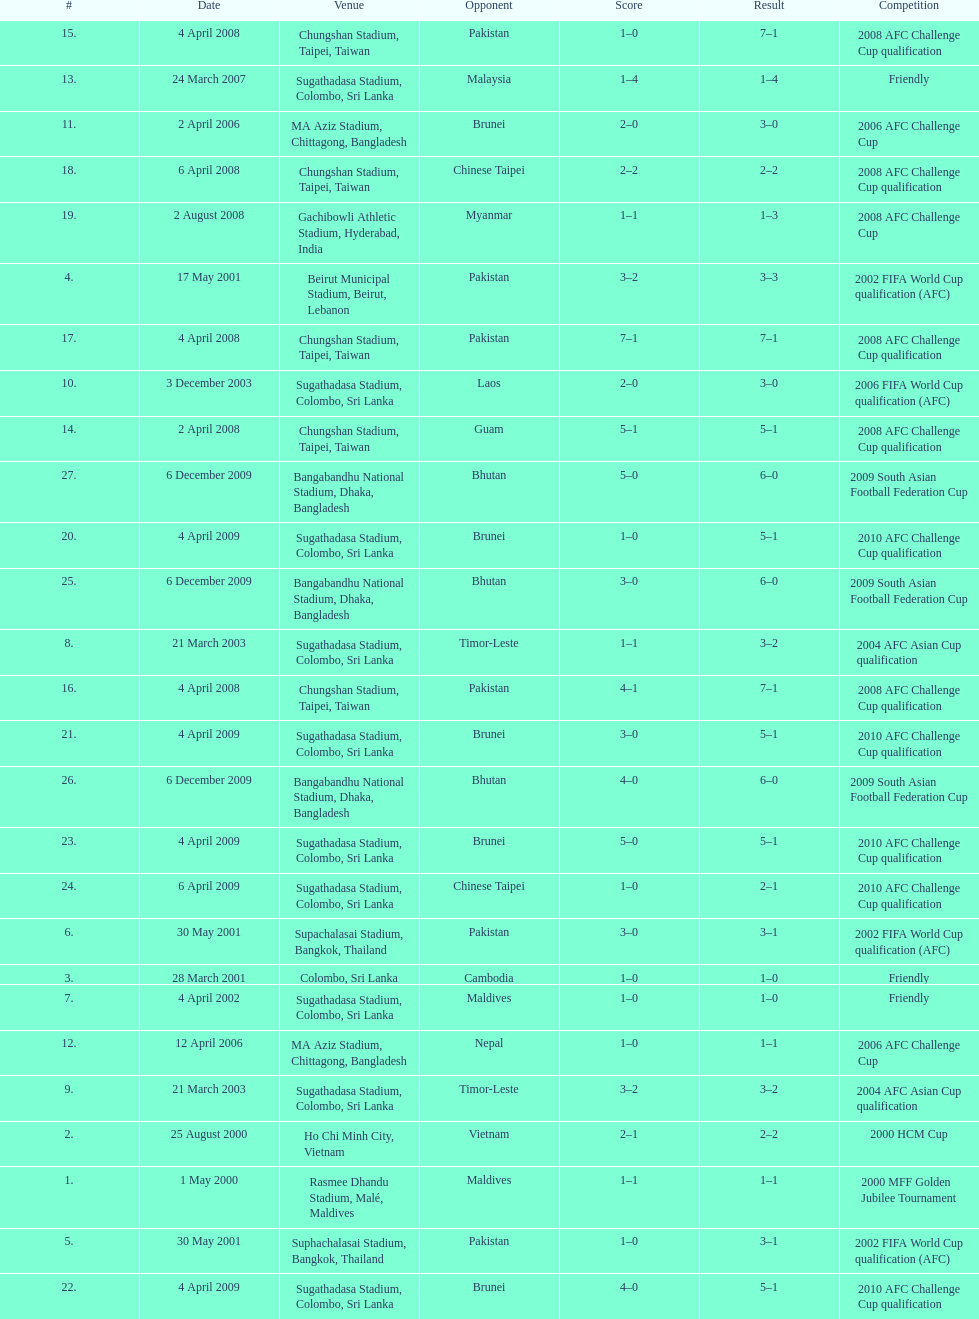Which team did this player face before pakistan on april 4, 2008? Guam. 